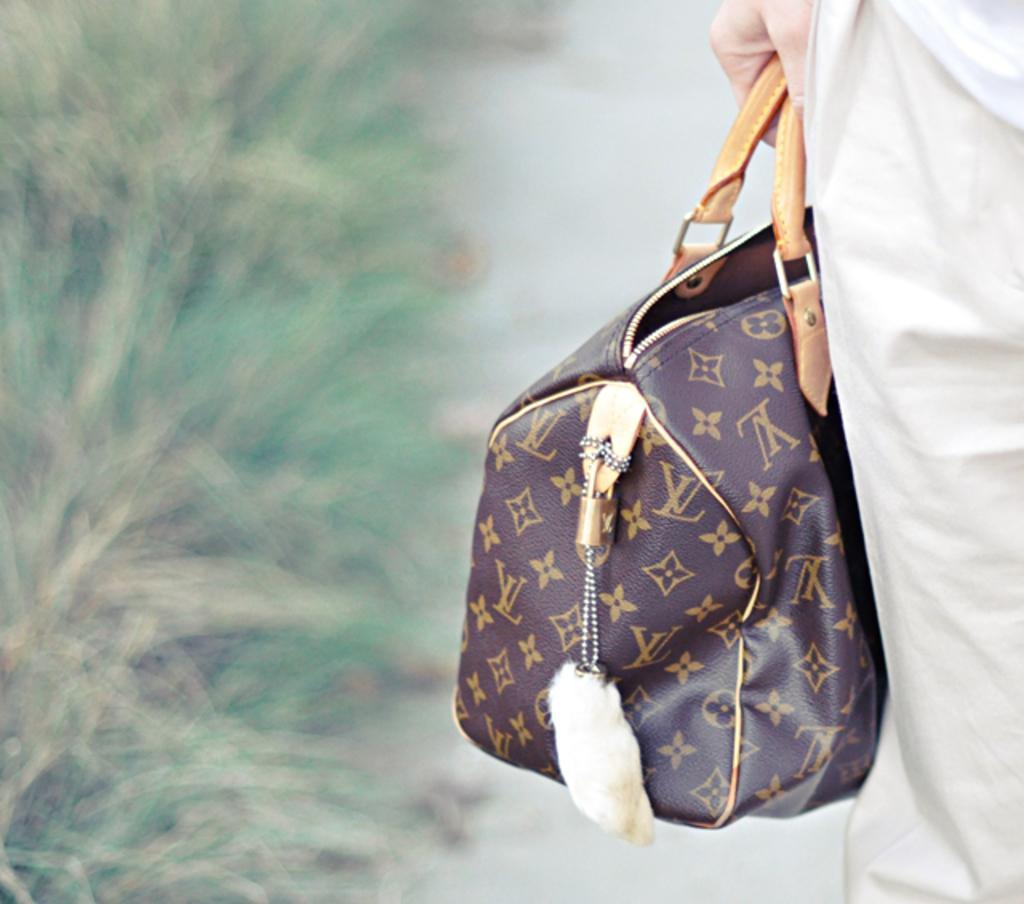Describe this image in one or two sentences. This picture is mainly highlighted with a person holding a bag in hand. 